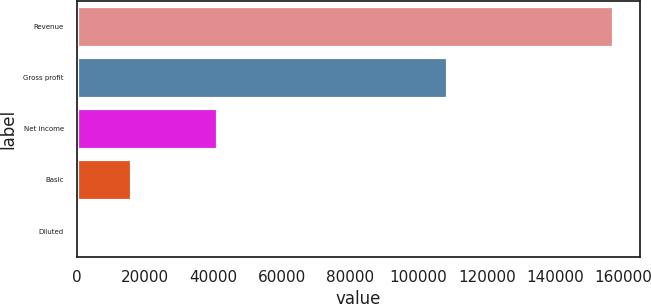Convert chart to OTSL. <chart><loc_0><loc_0><loc_500><loc_500><bar_chart><fcel>Revenue<fcel>Gross profit<fcel>Net income<fcel>Basic<fcel>Diluted<nl><fcel>156904<fcel>108470<fcel>40919<fcel>15691.3<fcel>1.04<nl></chart> 